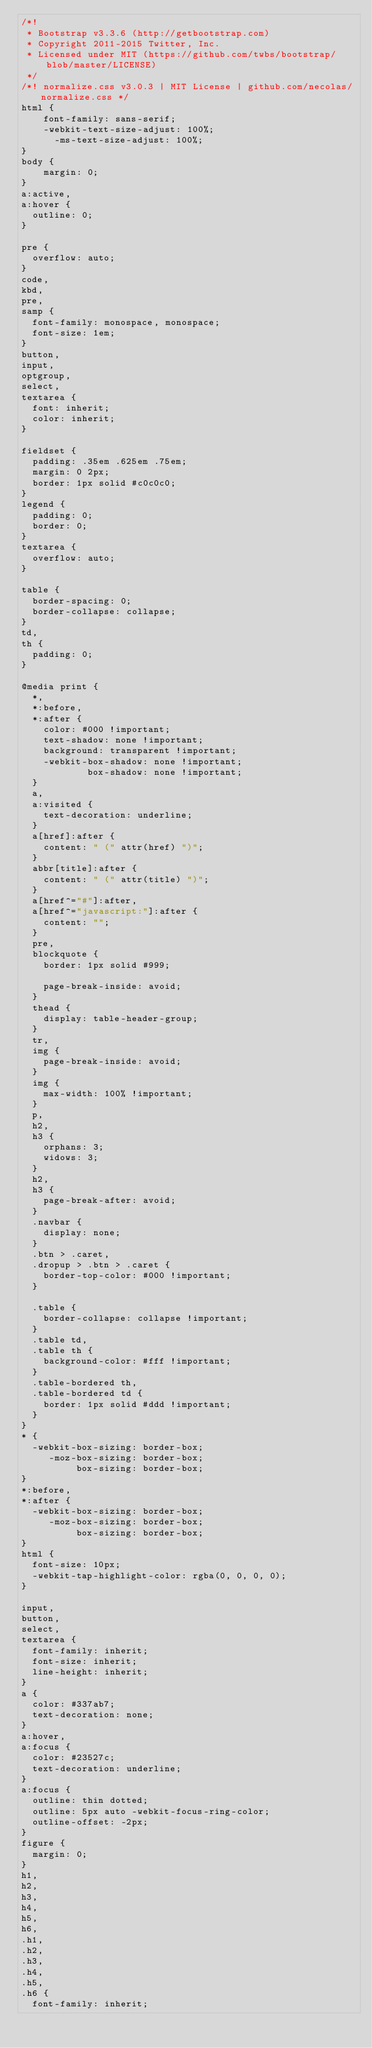<code> <loc_0><loc_0><loc_500><loc_500><_CSS_>/*!
 * Bootstrap v3.3.6 (http://getbootstrap.com)
 * Copyright 2011-2015 Twitter, Inc.
 * Licensed under MIT (https://github.com/twbs/bootstrap/blob/master/LICENSE)
 */
/*! normalize.css v3.0.3 | MIT License | github.com/necolas/normalize.css */
html {
	font-family: sans-serif;
	-webkit-text-size-adjust: 100%;
      -ms-text-size-adjust: 100%;
}
body {
	margin: 0;
}
a:active,
a:hover {
  outline: 0;
}

pre {
  overflow: auto;
}
code,
kbd,
pre,
samp {
  font-family: monospace, monospace;
  font-size: 1em;
}
button,
input,
optgroup,
select,
textarea {
  font: inherit;
  color: inherit;
}

fieldset {
  padding: .35em .625em .75em;
  margin: 0 2px;
  border: 1px solid #c0c0c0;
}
legend {
  padding: 0;
  border: 0;
}
textarea {
  overflow: auto;
}

table {
  border-spacing: 0;
  border-collapse: collapse;
}
td,
th {
  padding: 0;
}

@media print {
  *,
  *:before,
  *:after {
    color: #000 !important;
    text-shadow: none !important;
    background: transparent !important;
    -webkit-box-shadow: none !important;
            box-shadow: none !important;
  }
  a,
  a:visited {
    text-decoration: underline;
  }
  a[href]:after {
    content: " (" attr(href) ")";
  }
  abbr[title]:after {
    content: " (" attr(title) ")";
  }
  a[href^="#"]:after,
  a[href^="javascript:"]:after {
    content: "";
  }
  pre,
  blockquote {
    border: 1px solid #999;

    page-break-inside: avoid;
  }
  thead {
    display: table-header-group;
  }
  tr,
  img {
    page-break-inside: avoid;
  }
  img {
    max-width: 100% !important;
  }
  p,
  h2,
  h3 {
    orphans: 3;
    widows: 3;
  }
  h2,
  h3 {
    page-break-after: avoid;
  }
  .navbar {
    display: none;
  }
  .btn > .caret,
  .dropup > .btn > .caret {
    border-top-color: #000 !important;
  }

  .table {
    border-collapse: collapse !important;
  }
  .table td,
  .table th {
    background-color: #fff !important;
  }
  .table-bordered th,
  .table-bordered td {
    border: 1px solid #ddd !important;
  }
}
* {
  -webkit-box-sizing: border-box;
     -moz-box-sizing: border-box;
          box-sizing: border-box;
}
*:before,
*:after {
  -webkit-box-sizing: border-box;
     -moz-box-sizing: border-box;
          box-sizing: border-box;
}
html {
  font-size: 10px;
  -webkit-tap-highlight-color: rgba(0, 0, 0, 0);
}

input,
button,
select,
textarea {
  font-family: inherit;
  font-size: inherit;
  line-height: inherit;
}
a {
  color: #337ab7;
  text-decoration: none;
}
a:hover,
a:focus {
  color: #23527c;
  text-decoration: underline;
}
a:focus {
  outline: thin dotted;
  outline: 5px auto -webkit-focus-ring-color;
  outline-offset: -2px;
}
figure {
  margin: 0;
}
h1,
h2,
h3,
h4,
h5,
h6,
.h1,
.h2,
.h3,
.h4,
.h5,
.h6 {
  font-family: inherit;</code> 